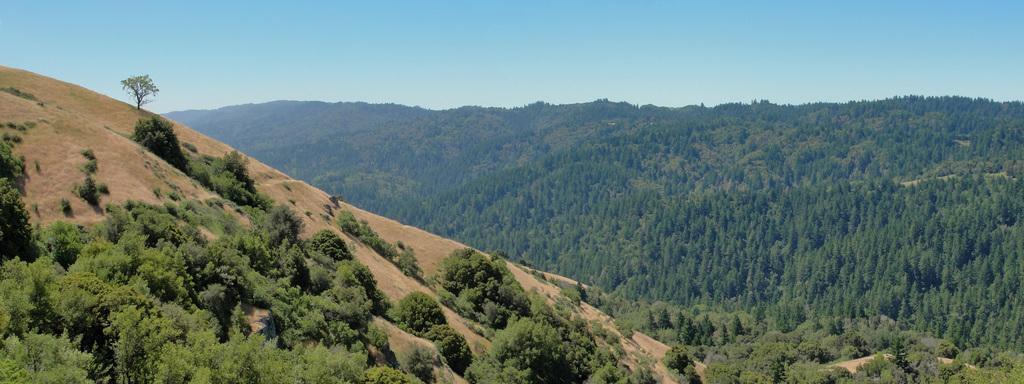Can you describe this image briefly? In this picture we can see some trees here, there is the sky at the top of the picture. 